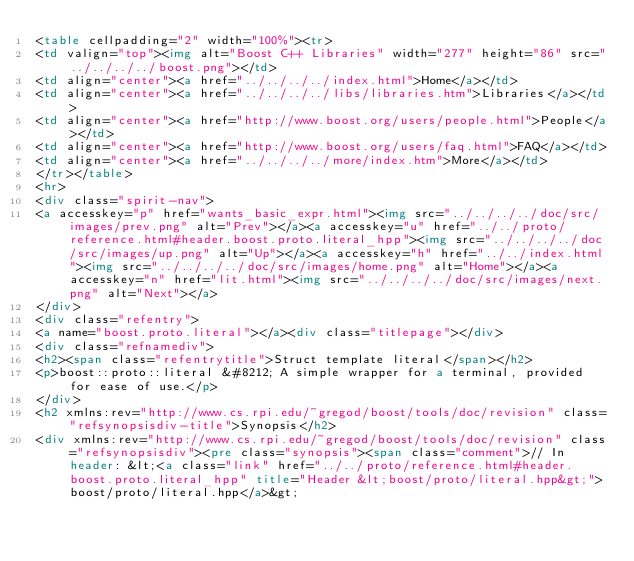<code> <loc_0><loc_0><loc_500><loc_500><_HTML_><table cellpadding="2" width="100%"><tr>
<td valign="top"><img alt="Boost C++ Libraries" width="277" height="86" src="../../../../boost.png"></td>
<td align="center"><a href="../../../../index.html">Home</a></td>
<td align="center"><a href="../../../../libs/libraries.htm">Libraries</a></td>
<td align="center"><a href="http://www.boost.org/users/people.html">People</a></td>
<td align="center"><a href="http://www.boost.org/users/faq.html">FAQ</a></td>
<td align="center"><a href="../../../../more/index.htm">More</a></td>
</tr></table>
<hr>
<div class="spirit-nav">
<a accesskey="p" href="wants_basic_expr.html"><img src="../../../../doc/src/images/prev.png" alt="Prev"></a><a accesskey="u" href="../../proto/reference.html#header.boost.proto.literal_hpp"><img src="../../../../doc/src/images/up.png" alt="Up"></a><a accesskey="h" href="../../index.html"><img src="../../../../doc/src/images/home.png" alt="Home"></a><a accesskey="n" href="lit.html"><img src="../../../../doc/src/images/next.png" alt="Next"></a>
</div>
<div class="refentry">
<a name="boost.proto.literal"></a><div class="titlepage"></div>
<div class="refnamediv">
<h2><span class="refentrytitle">Struct template literal</span></h2>
<p>boost::proto::literal &#8212; A simple wrapper for a terminal, provided for ease of use.</p>
</div>
<h2 xmlns:rev="http://www.cs.rpi.edu/~gregod/boost/tools/doc/revision" class="refsynopsisdiv-title">Synopsis</h2>
<div xmlns:rev="http://www.cs.rpi.edu/~gregod/boost/tools/doc/revision" class="refsynopsisdiv"><pre class="synopsis"><span class="comment">// In header: &lt;<a class="link" href="../../proto/reference.html#header.boost.proto.literal_hpp" title="Header &lt;boost/proto/literal.hpp&gt;">boost/proto/literal.hpp</a>&gt;
</code> 